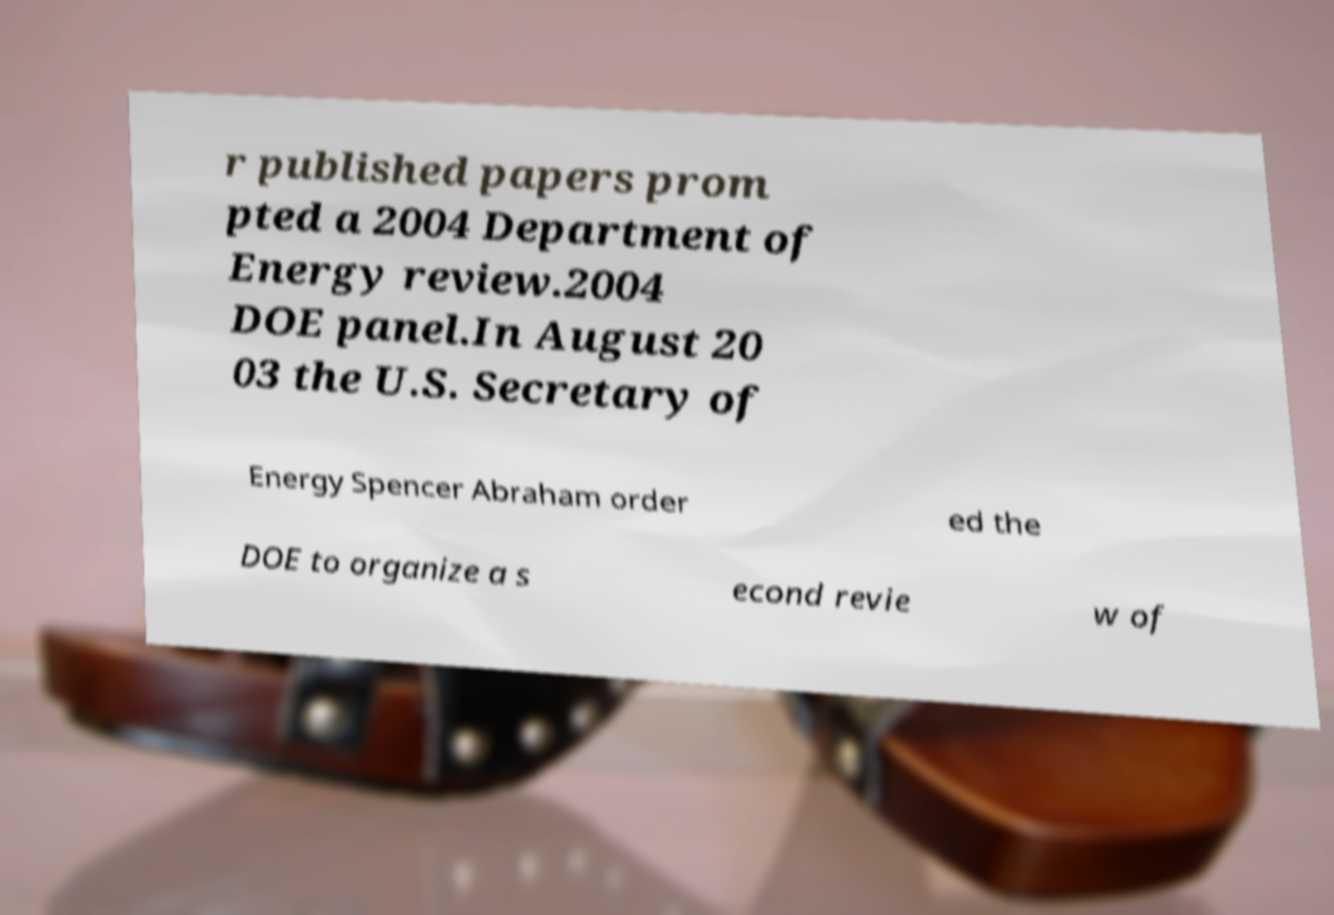I need the written content from this picture converted into text. Can you do that? r published papers prom pted a 2004 Department of Energy review.2004 DOE panel.In August 20 03 the U.S. Secretary of Energy Spencer Abraham order ed the DOE to organize a s econd revie w of 